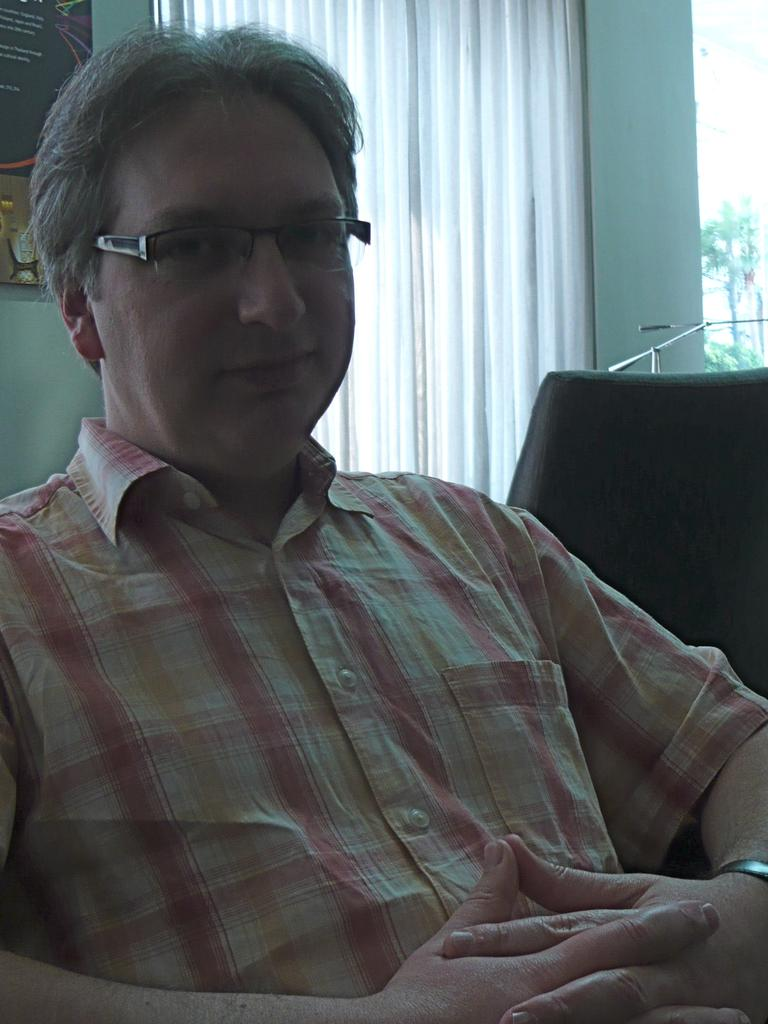Who is present in the image? There is a man in the image. What is the man doing in the image? The man is looking to his side. What is the man wearing in the image? The man is wearing a shirt and spectacles. What can be seen in the background of the image? There is a window curtain visible in the image. What furniture is present in the image? There is a chair on the right side of the image. What type of farm animals can be seen in the foggy background of the image? There is no farm or fog present in the image; it features a man looking to his side, wearing a shirt and spectacles, with a window curtain and a chair in the background. 